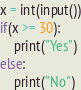<code> <loc_0><loc_0><loc_500><loc_500><_Python_>x = int(input())
if(x >= 30):
    print("Yes")
else:
    print("No")</code> 